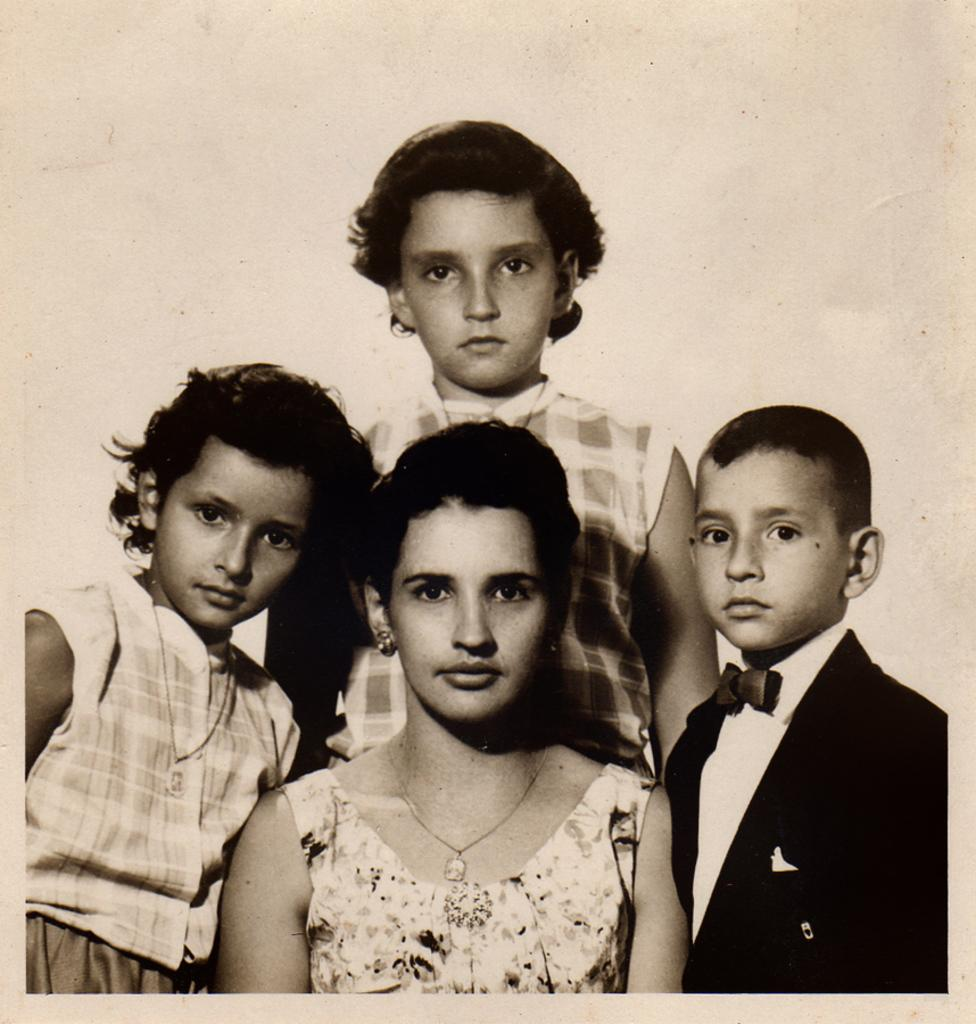What is the color scheme of the image? The image is in black and white. Can you describe the people in the image? There are people in the image, but no specific details about their appearance or actions are provided. What can be seen in the background of the image? There is a wall in the background of the image. What is the person wearing in the image? One person is wearing a coat and a tie. What type of government is depicted in the image? There is no indication of a government or any political context in the image. --- 